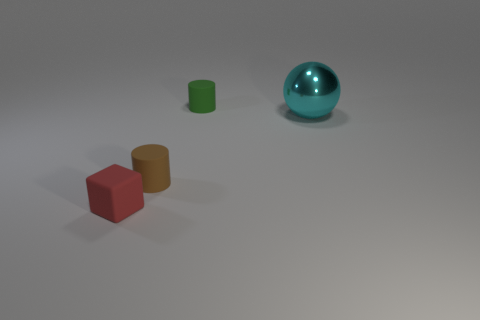Is the number of green rubber objects less than the number of large purple blocks?
Offer a very short reply. No. What is the color of the other object that is the same shape as the small green object?
Offer a very short reply. Brown. Is there anything else that is the same shape as the big object?
Provide a succinct answer. No. Are there more tiny brown cylinders than big yellow rubber cubes?
Make the answer very short. Yes. What number of other things are the same material as the big sphere?
Make the answer very short. 0. There is a thing right of the small cylinder behind the object that is on the right side of the tiny green rubber object; what is its shape?
Your response must be concise. Sphere. Are there fewer green rubber objects on the right side of the big thing than green cylinders left of the green matte cylinder?
Give a very brief answer. No. Is there a small object that has the same color as the big metallic sphere?
Offer a very short reply. No. Is the small green object made of the same material as the small cylinder that is to the left of the green thing?
Your answer should be compact. Yes. Is there a rubber cube to the right of the cylinder that is behind the big cyan shiny object?
Make the answer very short. No. 